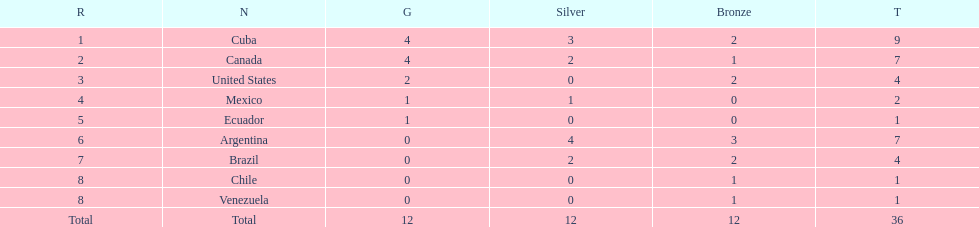Which ranking is mexico? 4. 